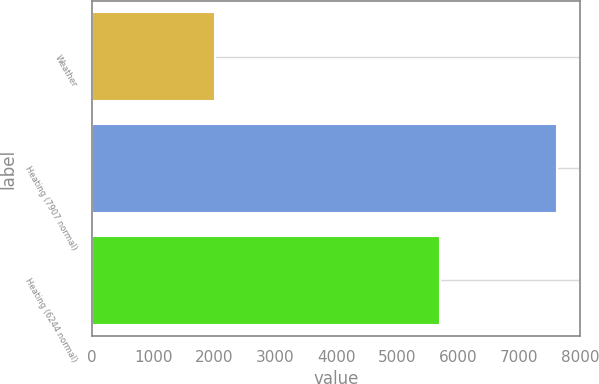Convert chart. <chart><loc_0><loc_0><loc_500><loc_500><bar_chart><fcel>Weather<fcel>Heating (7907 normal)<fcel>Heating (6244 normal)<nl><fcel>2017<fcel>7625<fcel>5707<nl></chart> 